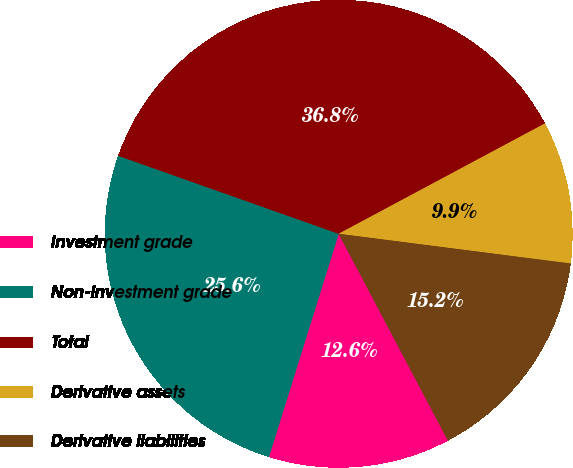Convert chart to OTSL. <chart><loc_0><loc_0><loc_500><loc_500><pie_chart><fcel>Investment grade<fcel>Non-investment grade<fcel>Total<fcel>Derivative assets<fcel>Derivative liabilities<nl><fcel>12.55%<fcel>25.59%<fcel>36.77%<fcel>9.85%<fcel>15.24%<nl></chart> 